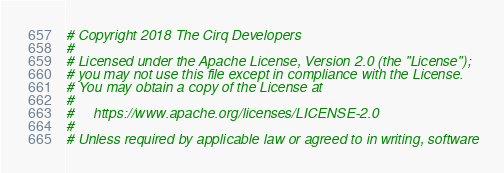<code> <loc_0><loc_0><loc_500><loc_500><_Python_># Copyright 2018 The Cirq Developers
#
# Licensed under the Apache License, Version 2.0 (the "License");
# you may not use this file except in compliance with the License.
# You may obtain a copy of the License at
#
#     https://www.apache.org/licenses/LICENSE-2.0
#
# Unless required by applicable law or agreed to in writing, software</code> 